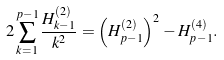<formula> <loc_0><loc_0><loc_500><loc_500>2 \sum _ { k = 1 } ^ { p - 1 } \frac { H _ { k - 1 } ^ { ( 2 ) } } { k ^ { 2 } } = \left ( H _ { p - 1 } ^ { ( 2 ) } \right ) ^ { 2 } - H _ { p - 1 } ^ { ( 4 ) } .</formula> 